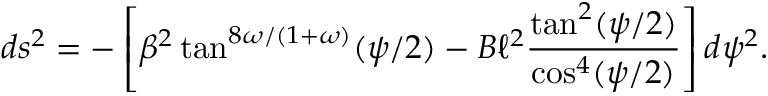Convert formula to latex. <formula><loc_0><loc_0><loc_500><loc_500>d s ^ { 2 } = - \left [ \beta ^ { 2 } \tan ^ { 8 \omega / ( 1 + \omega ) } ( \psi / 2 ) - B \ell ^ { 2 } \frac { \tan ^ { 2 } ( \psi / 2 ) } { \cos ^ { 4 } ( \psi / 2 ) } \right ] d \psi ^ { 2 } .</formula> 